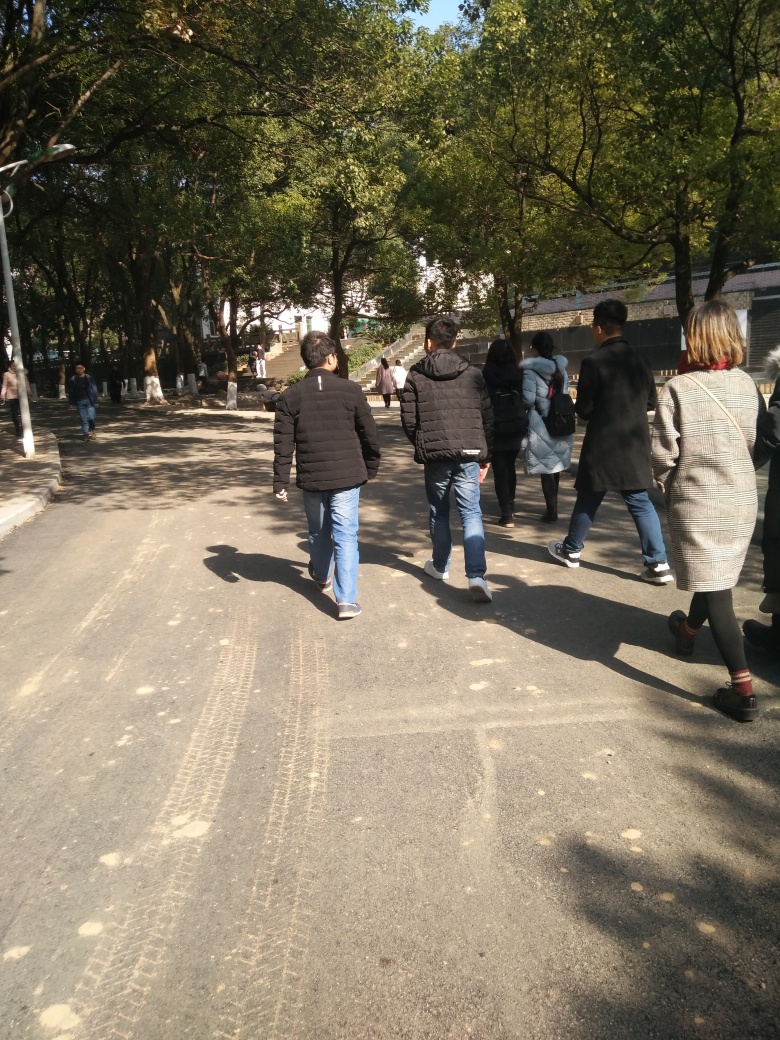Is the background relatively clear?
 Yes 